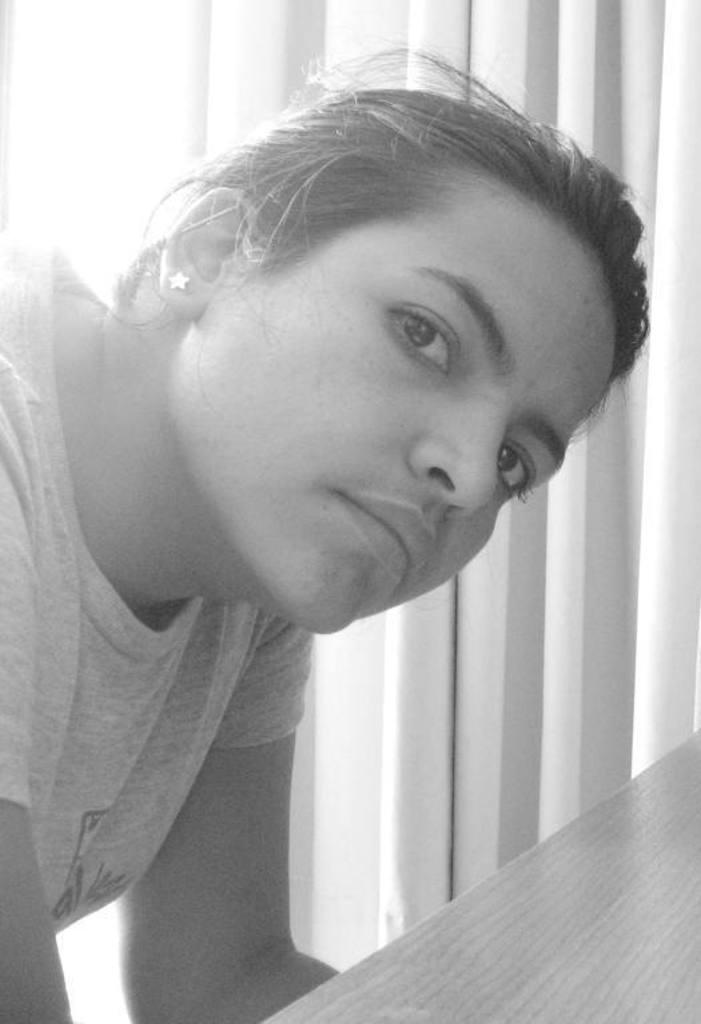Who is present in the image? There is a woman in the image. What type of object can be seen in the image? There is a wooden object in the image. What can be seen in the background of the image? There are curtains in the background of the image. Where is the nest located in the image? There is no nest present in the image. What type of shock can be seen in the image? There is no shock present in the image. 